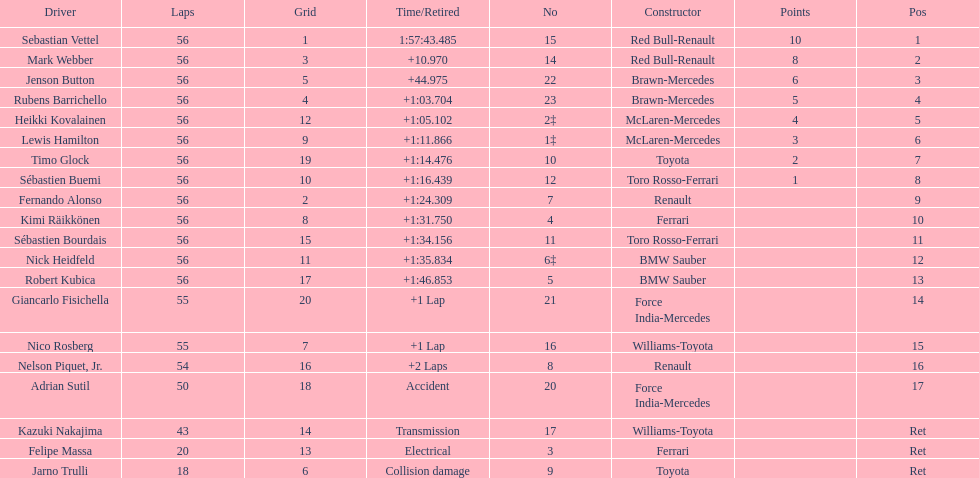What is the total number of drivers on the list? 20. 